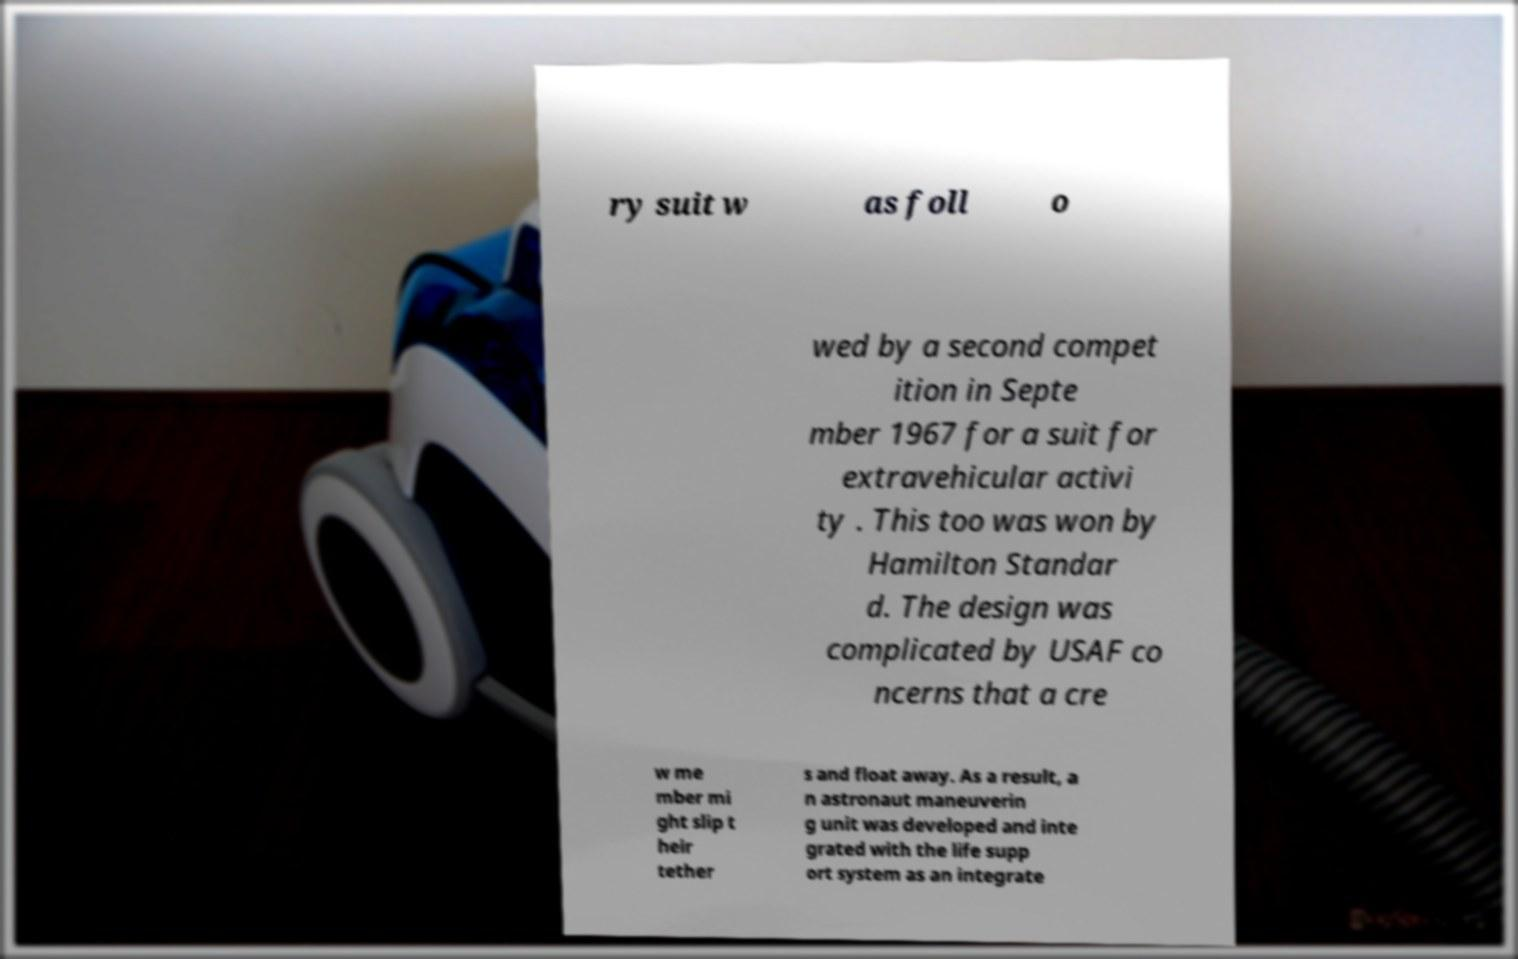Could you extract and type out the text from this image? ry suit w as foll o wed by a second compet ition in Septe mber 1967 for a suit for extravehicular activi ty . This too was won by Hamilton Standar d. The design was complicated by USAF co ncerns that a cre w me mber mi ght slip t heir tether s and float away. As a result, a n astronaut maneuverin g unit was developed and inte grated with the life supp ort system as an integrate 